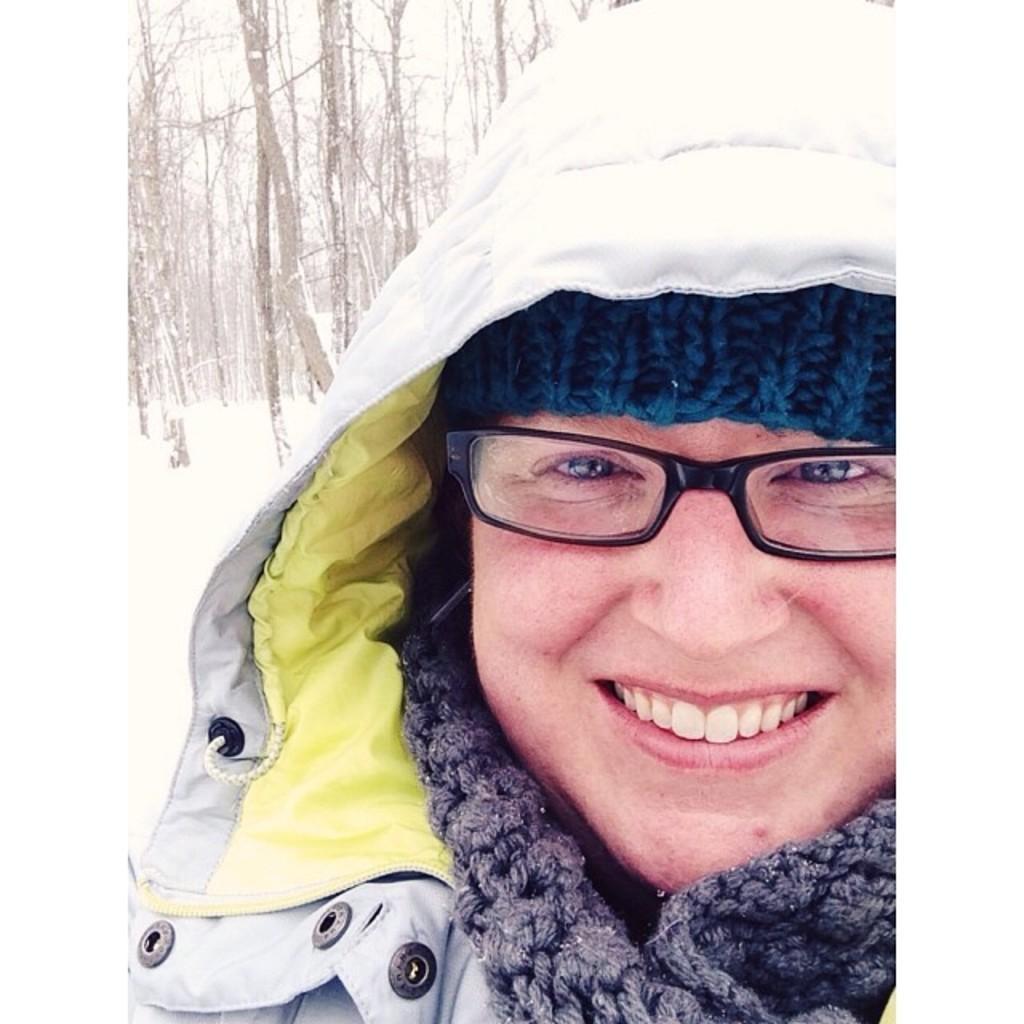Please provide a concise description of this image. In this image we can see there is a person with a smile on his face. In the background there is a snow and trees. 